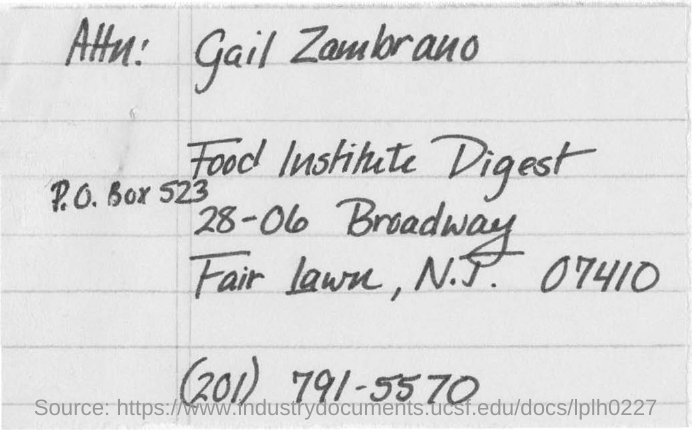Outline some significant characteristics in this image. The P.O.Box number provided is P.O. Box 523. 